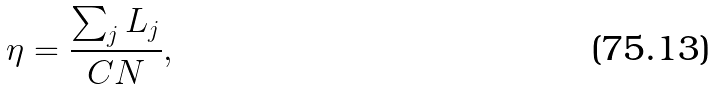Convert formula to latex. <formula><loc_0><loc_0><loc_500><loc_500>\eta = \frac { \sum _ { j } L _ { j } } { C N } ,</formula> 